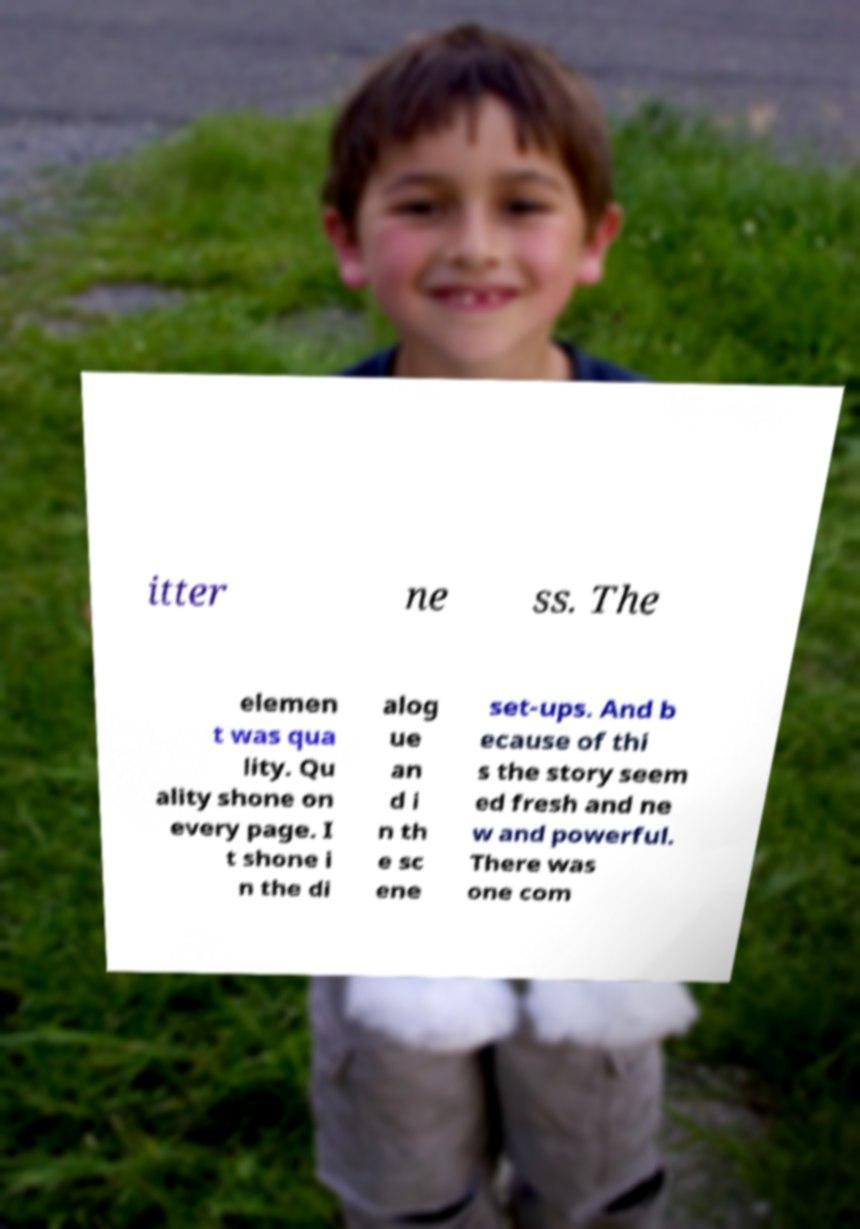What messages or text are displayed in this image? I need them in a readable, typed format. itter ne ss. The elemen t was qua lity. Qu ality shone on every page. I t shone i n the di alog ue an d i n th e sc ene set-ups. And b ecause of thi s the story seem ed fresh and ne w and powerful. There was one com 